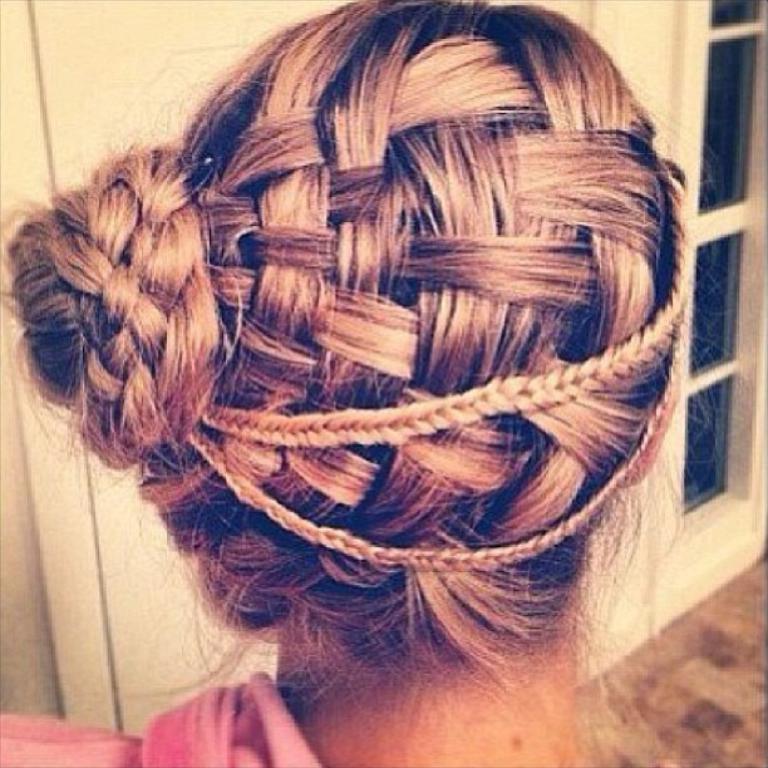Describe this image in one or two sentences. In this image in front there is a person. In the background of the image there is a wall. There is a glass window. At the bottom of the image there is a floor. 